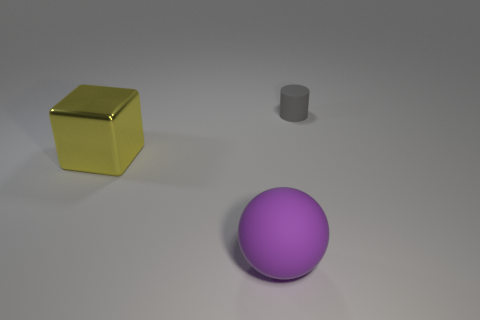Is the number of small gray matte objects greater than the number of yellow rubber cubes?
Give a very brief answer. Yes. Is the big matte thing the same shape as the small gray matte thing?
Give a very brief answer. No. What material is the big thing that is behind the rubber thing in front of the gray thing?
Your answer should be very brief. Metal. Is the yellow metal block the same size as the cylinder?
Provide a short and direct response. No. There is a large thing on the left side of the big rubber sphere; is there a gray rubber cylinder that is in front of it?
Provide a short and direct response. No. There is a rubber object behind the rubber ball; what is its shape?
Your answer should be compact. Cylinder. What number of purple rubber balls are on the right side of the rubber thing that is on the left side of the thing behind the large yellow object?
Your response must be concise. 0. Does the shiny object have the same size as the matte object behind the large rubber thing?
Ensure brevity in your answer.  No. How big is the rubber thing to the right of the rubber object in front of the tiny object?
Your response must be concise. Small. How many other gray cylinders are made of the same material as the cylinder?
Provide a succinct answer. 0. 